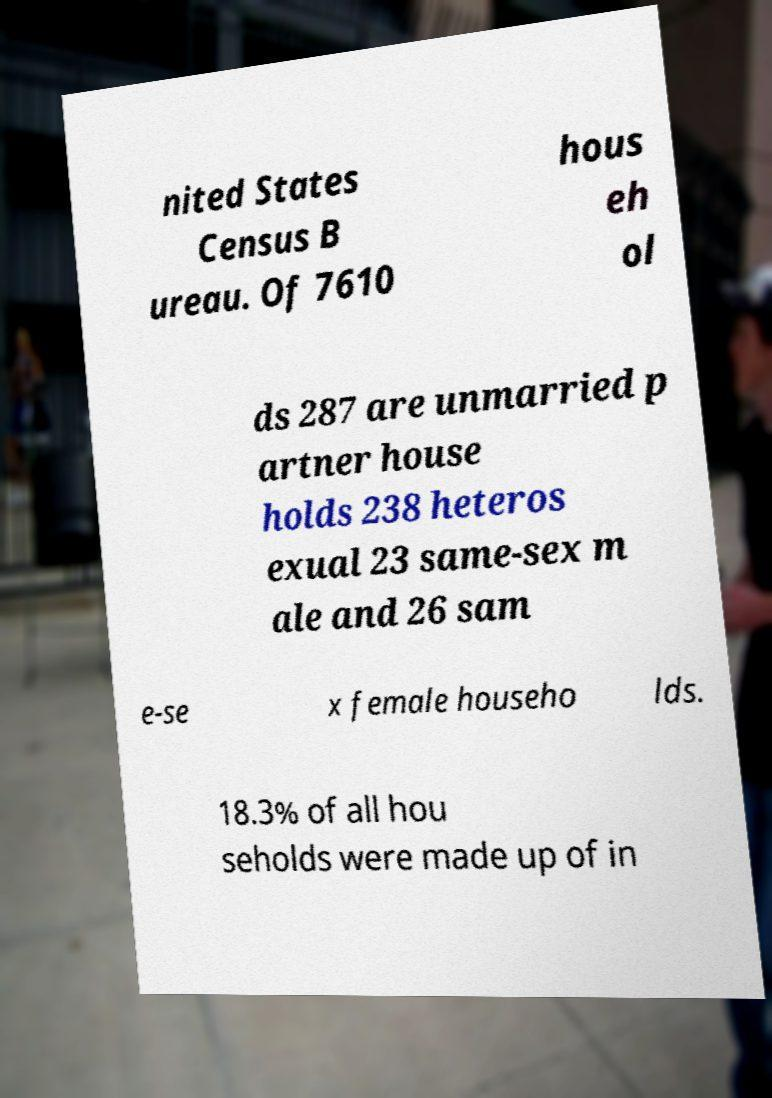Can you read and provide the text displayed in the image?This photo seems to have some interesting text. Can you extract and type it out for me? nited States Census B ureau. Of 7610 hous eh ol ds 287 are unmarried p artner house holds 238 heteros exual 23 same-sex m ale and 26 sam e-se x female househo lds. 18.3% of all hou seholds were made up of in 